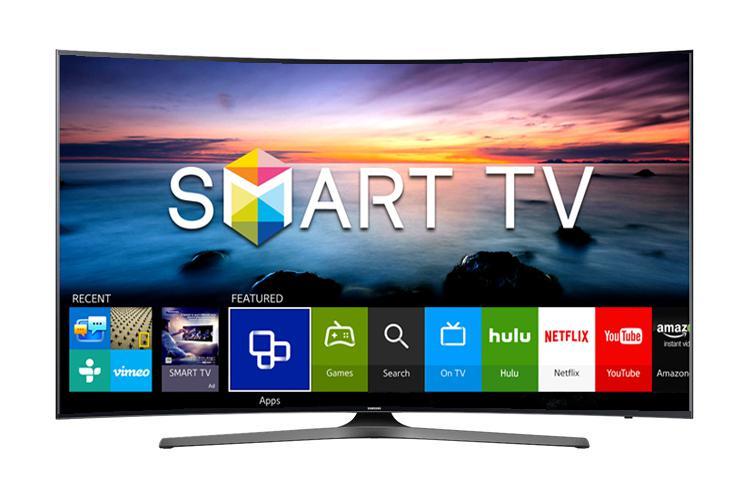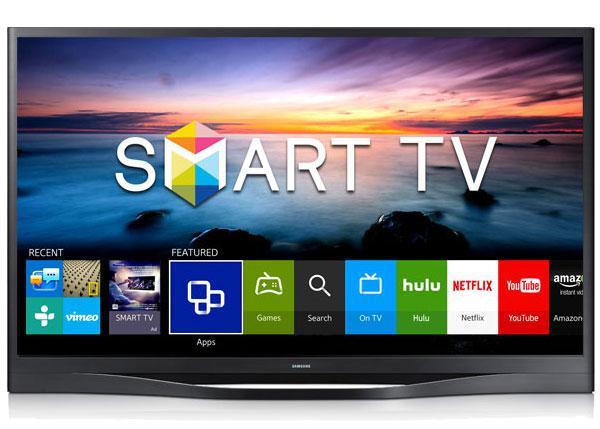The first image is the image on the left, the second image is the image on the right. For the images displayed, is the sentence "There are apps displayed on the television." factually correct? Answer yes or no. Yes. 